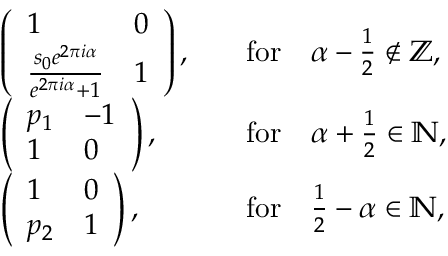<formula> <loc_0><loc_0><loc_500><loc_500>\begin{array} { r l r l } & { \left ( \begin{array} { l l } { 1 } & { 0 } \\ { \frac { s _ { 0 } e ^ { 2 \pi i \alpha } } { e ^ { 2 \pi i \alpha } + 1 } } & { 1 } \end{array} \right ) , } & & { f o r \quad \alpha - \frac { 1 } { 2 } \notin \mathbb { Z } , } \\ & { \left ( \begin{array} { l l } { p _ { 1 } } & { - 1 } \\ { 1 } & { 0 } \end{array} \right ) , } & & { f o r \quad \alpha + \frac { 1 } { 2 } \in \mathbb { N } , } \\ & { \left ( \begin{array} { l l } { 1 } & { 0 } \\ { p _ { 2 } } & { 1 } \end{array} \right ) , } & & { f o r \quad \frac { 1 } { 2 } - \alpha \in \mathbb { N } , } \end{array}</formula> 